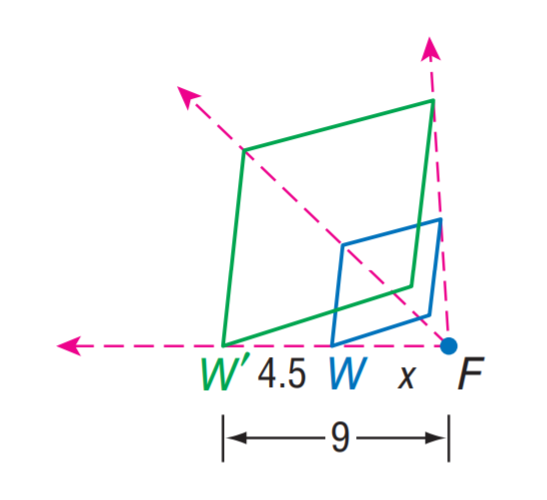What geometric transformations can be observed from the image? From the image, we can observe several geometric transformations. Firstly, there is a dilation where W' is a scaled-down version of W by a factor of 2. Additionally, we can infer that there's a translation involved, as W' is not located in the same position as W, but has been shifted linearly from its original position. Other transformations like rotation or reflection are not explicitly shown but could also be considered depending on the orientation and position of other unseen sides of the objects if they were presented within a three-dimensional context. 